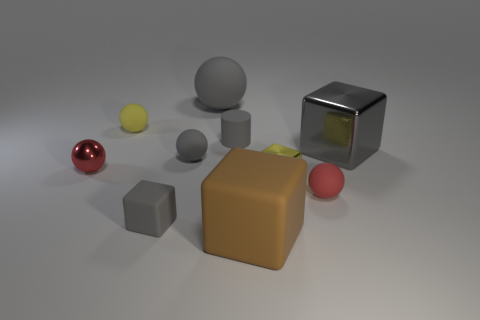Subtract all red matte balls. How many balls are left? 4 Subtract all yellow balls. How many balls are left? 4 Subtract all blue spheres. Subtract all green cylinders. How many spheres are left? 5 Subtract all blocks. How many objects are left? 6 Add 7 large brown matte objects. How many large brown matte objects exist? 8 Subtract 1 yellow spheres. How many objects are left? 9 Subtract all brown objects. Subtract all big shiny blocks. How many objects are left? 8 Add 8 tiny yellow things. How many tiny yellow things are left? 10 